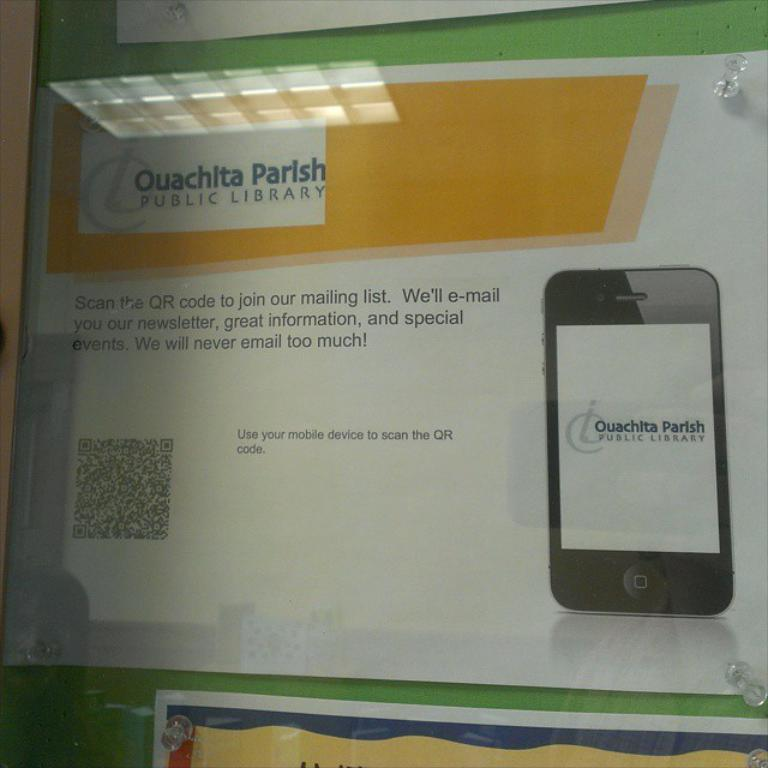Provide a one-sentence caption for the provided image. An sign to join the mailing list at Ouachita Parish Public Library. 